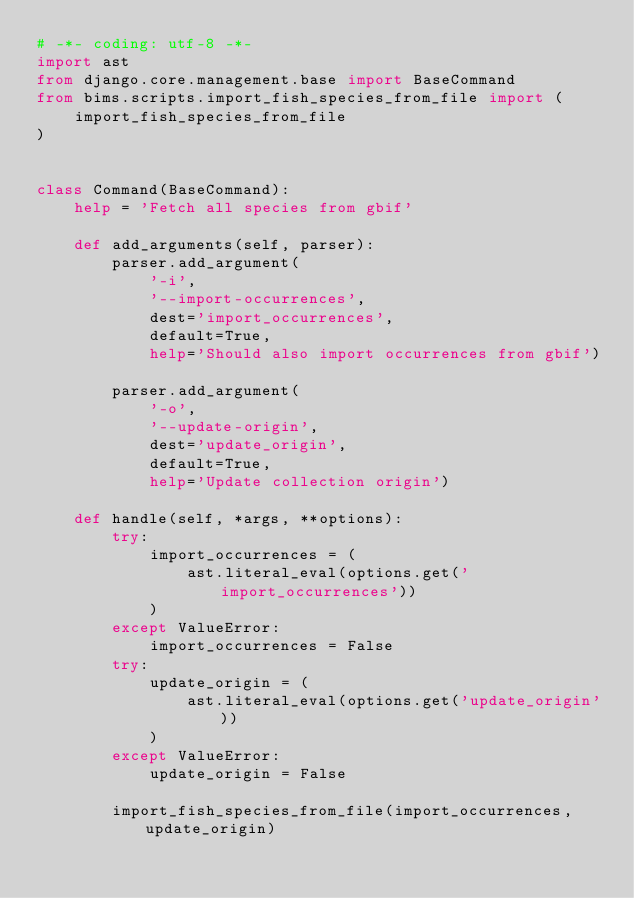Convert code to text. <code><loc_0><loc_0><loc_500><loc_500><_Python_># -*- coding: utf-8 -*-
import ast
from django.core.management.base import BaseCommand
from bims.scripts.import_fish_species_from_file import (
    import_fish_species_from_file
)


class Command(BaseCommand):
    help = 'Fetch all species from gbif'

    def add_arguments(self, parser):
        parser.add_argument(
            '-i',
            '--import-occurrences',
            dest='import_occurrences',
            default=True,
            help='Should also import occurrences from gbif')

        parser.add_argument(
            '-o',
            '--update-origin',
            dest='update_origin',
            default=True,
            help='Update collection origin')

    def handle(self, *args, **options):
        try:
            import_occurrences = (
                ast.literal_eval(options.get('import_occurrences'))
            )
        except ValueError:
            import_occurrences = False
        try:
            update_origin = (
                ast.literal_eval(options.get('update_origin'))
            )
        except ValueError:
            update_origin = False

        import_fish_species_from_file(import_occurrences, update_origin)
</code> 